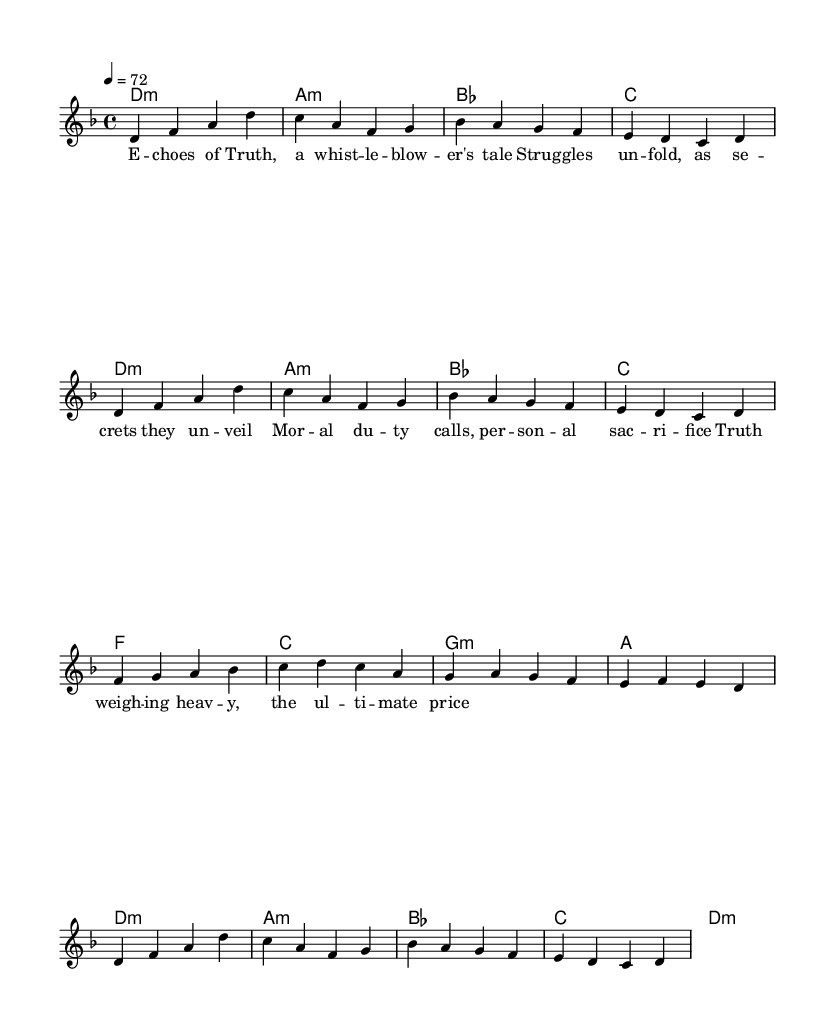What is the key signature of this music? The key signature is D minor, which consists of one flat (B flat). You can determine this by looking at the key signature notation at the beginning of the sheet music.
Answer: D minor What is the time signature of this music? The time signature indicated at the beginning of the music is 4/4. This means there are four beats in each measure, and the quarter note gets one beat. The time signature can be found next to the key signature.
Answer: 4/4 What is the tempo marking for this piece? The tempo marking is 4 equals 72, indicating that each quarter note should be played at a speed of 72 beats per minute. This is visually noted in the tempo indication at the beginning of the score.
Answer: 72 How many measures are in the piece? The piece has 16 measures in total, which can be counted by observing the lines dividing the sections of music on the staff. Each line represents a measure.
Answer: 16 What type of song is represented by this music? This music represents an indie ballad, particularly one that tells the story of a whistleblower and their struggles. This is inferred from the lyrical content, which speaks to themes of truth, moral duty, and sacrifice.
Answer: Indie ballad What is the chord progression in the first two measures? The chord progression in the first two measures consists of D minor and A minor. This can be determined by looking at the chord symbols placed above the staff in each measure.
Answer: D minor, A minor What thematic elements are depicted in the lyrics? The lyrics convey themes of truth, struggle, and sacrifice, reflecting the experiences of whistleblowers. This can be observed by reading the words aligned with the melody on the sheet music.
Answer: Truth, struggle, sacrifice 